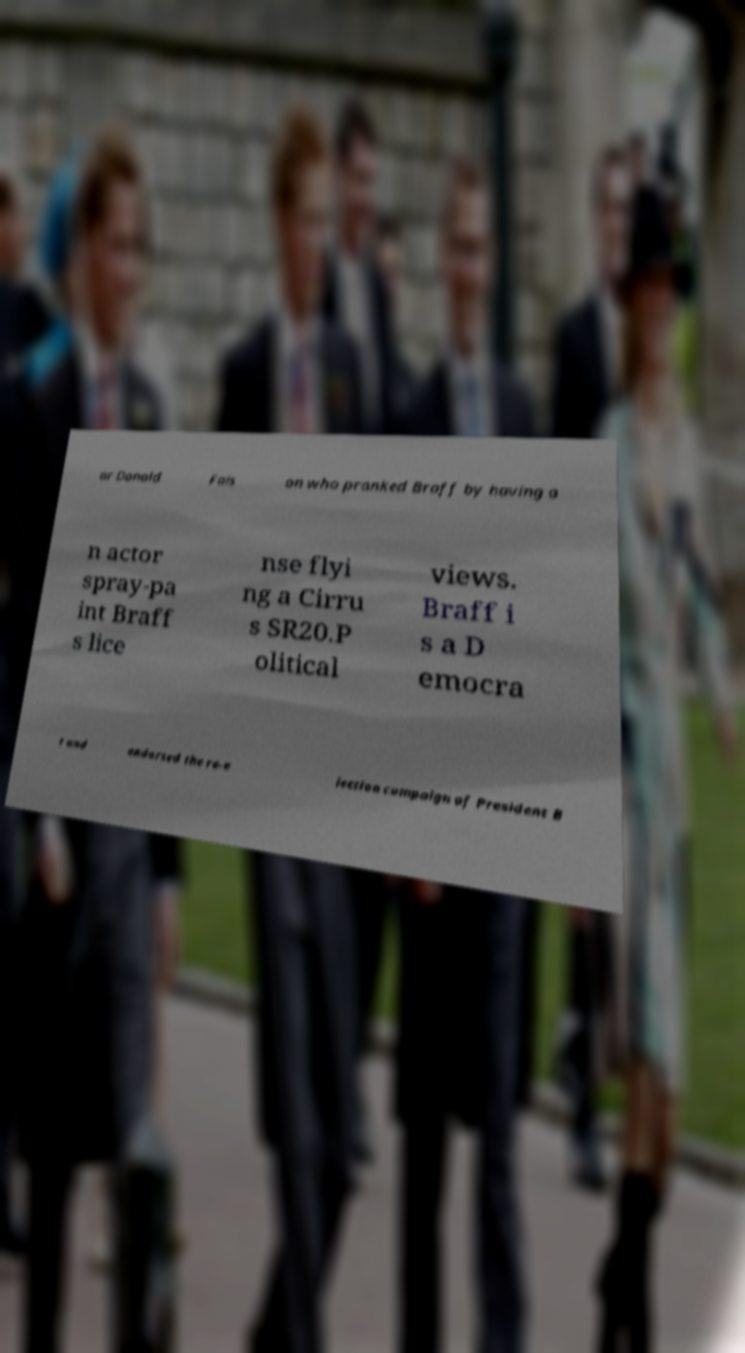For documentation purposes, I need the text within this image transcribed. Could you provide that? ar Donald Fais on who pranked Braff by having a n actor spray-pa int Braff s lice nse flyi ng a Cirru s SR20.P olitical views. Braff i s a D emocra t and endorsed the re-e lection campaign of President B 